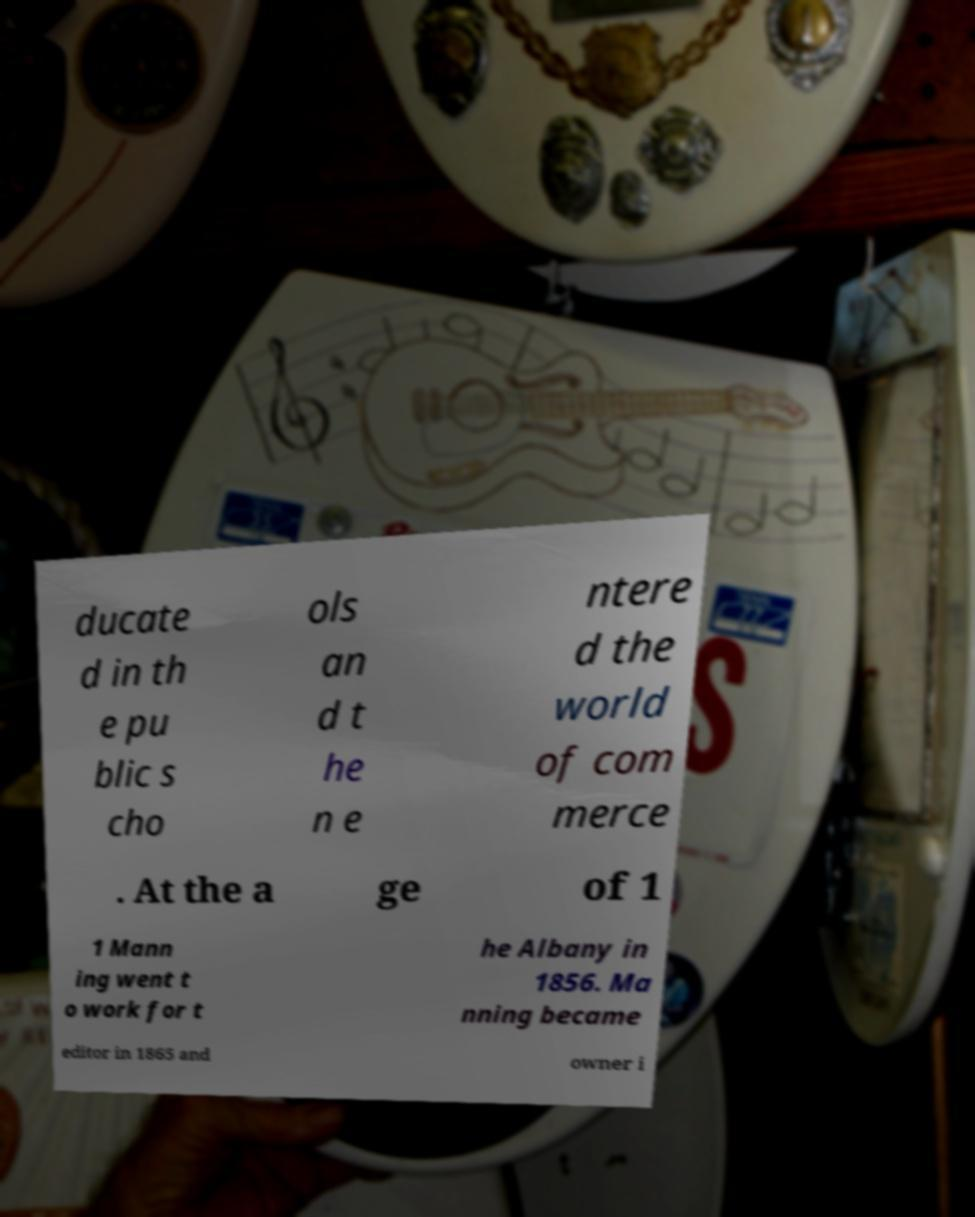What messages or text are displayed in this image? I need them in a readable, typed format. ducate d in th e pu blic s cho ols an d t he n e ntere d the world of com merce . At the a ge of 1 1 Mann ing went t o work for t he Albany in 1856. Ma nning became editor in 1865 and owner i 